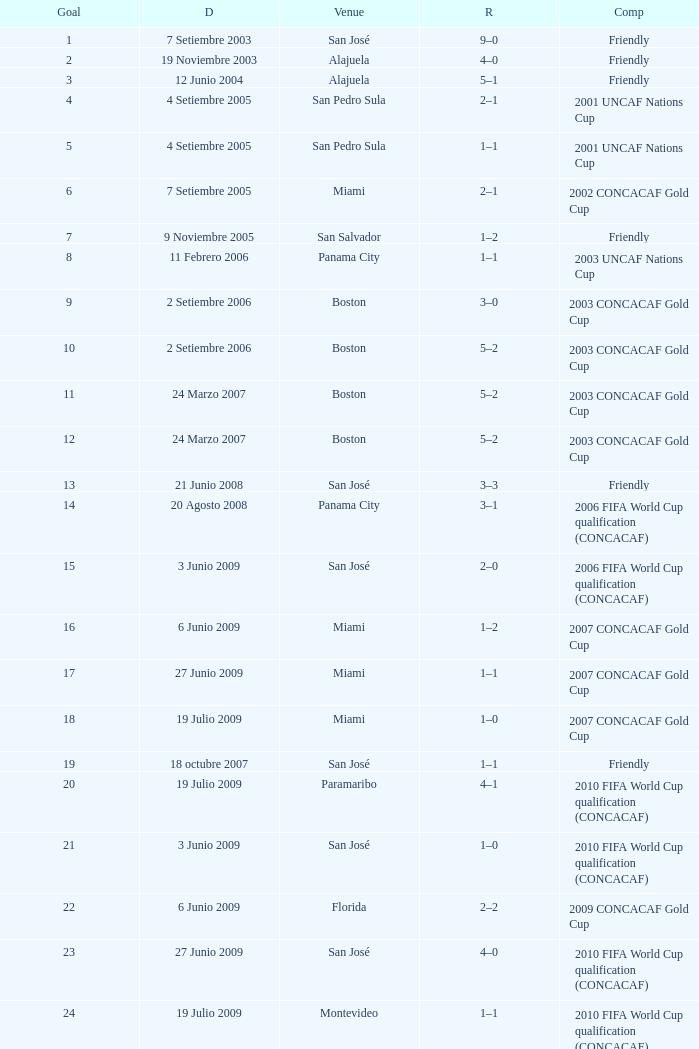How was the competition in which 6 goals were made? 2002 CONCACAF Gold Cup. 